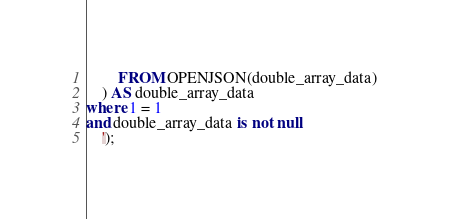Convert code to text. <code><loc_0><loc_0><loc_500><loc_500><_SQL_>	    FROM OPENJSON(double_array_data)
    ) AS double_array_data
where 1 = 1
and double_array_data is not null
    ');

</code> 